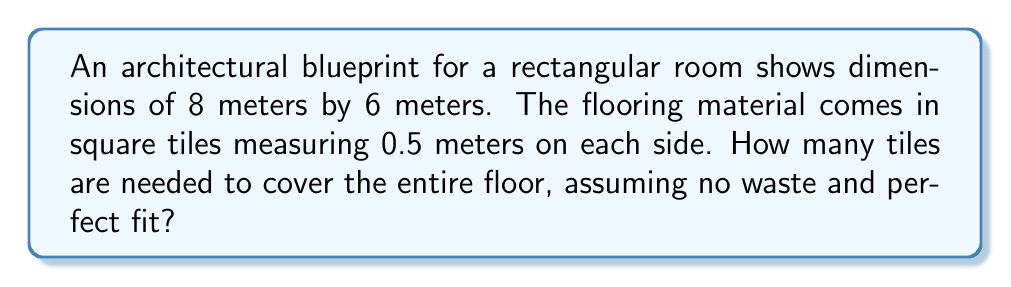Could you help me with this problem? To solve this problem, we'll follow these steps:

1. Calculate the total area of the room:
   $$A_{room} = length \times width = 8 \text{ m} \times 6 \text{ m} = 48 \text{ m}^2$$

2. Calculate the area of a single tile:
   $$A_{tile} = side \times side = 0.5 \text{ m} \times 0.5 \text{ m} = 0.25 \text{ m}^2$$

3. Calculate the number of tiles needed:
   $$N_{tiles} = \frac{A_{room}}{A_{tile}} = \frac{48 \text{ m}^2}{0.25 \text{ m}^2} = 192$$

Therefore, 192 tiles are needed to cover the entire floor.

[asy]
unitsize(1cm);
draw((0,0)--(8,0)--(8,6)--(0,6)--cycle);
label("8 m", (4,-0.5));
label("6 m", (8.5,3), E);
for(int i=0; i<16; ++i) {
  for(int j=0; j<12; ++j) {
    draw((i*0.5,j*0.5)--((i+1)*0.5,j*0.5)--((i+1)*0.5,(j+1)*0.5)--(i*0.5,(j+1)*0.5)--cycle);
  }
}
label("0.5 m", (0.25,-0.5));
[/asy]
Answer: 192 tiles 